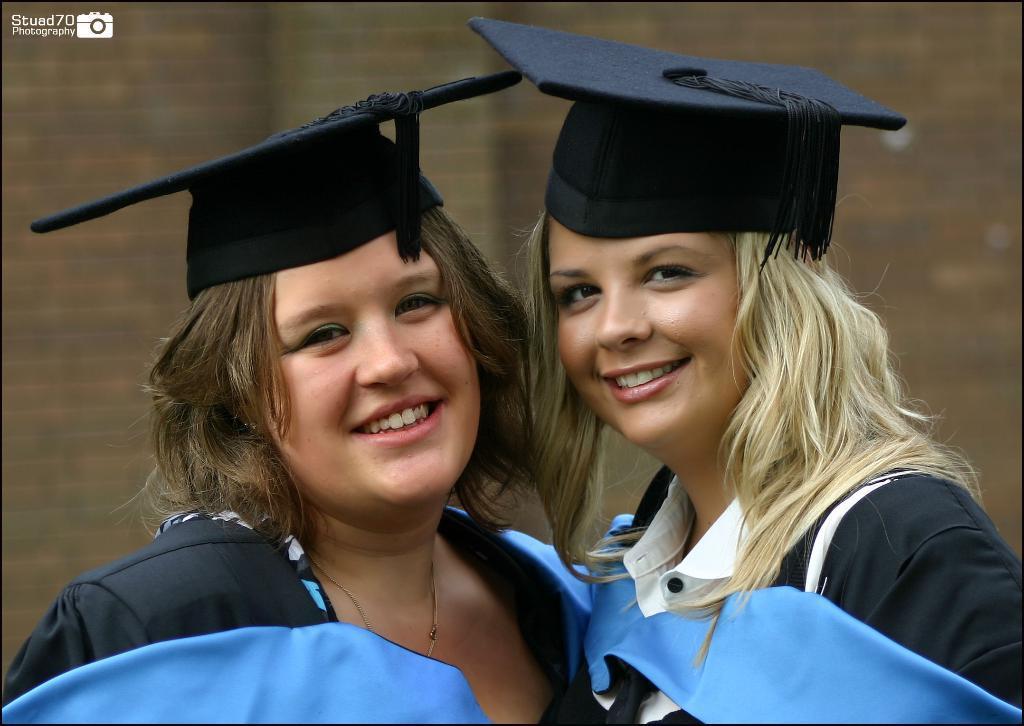How would you summarize this image in a sentence or two? In this image we can see two girls wearing a cap and looking at someone. 